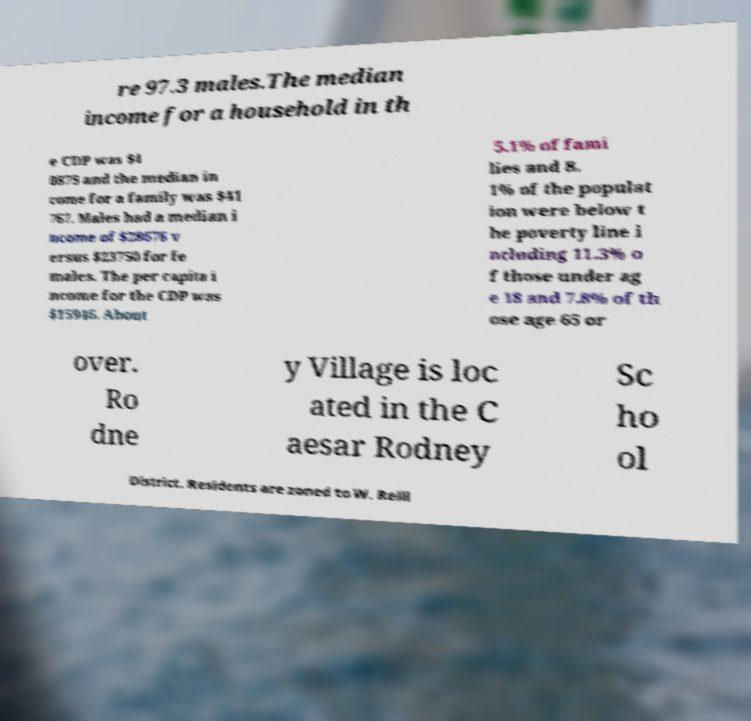For documentation purposes, I need the text within this image transcribed. Could you provide that? re 97.3 males.The median income for a household in th e CDP was $4 0875 and the median in come for a family was $41 767. Males had a median i ncome of $28676 v ersus $23750 for fe males. The per capita i ncome for the CDP was $15946. About 5.1% of fami lies and 8. 1% of the populat ion were below t he poverty line i ncluding 11.3% o f those under ag e 18 and 7.8% of th ose age 65 or over. Ro dne y Village is loc ated in the C aesar Rodney Sc ho ol District. Residents are zoned to W. Reill 